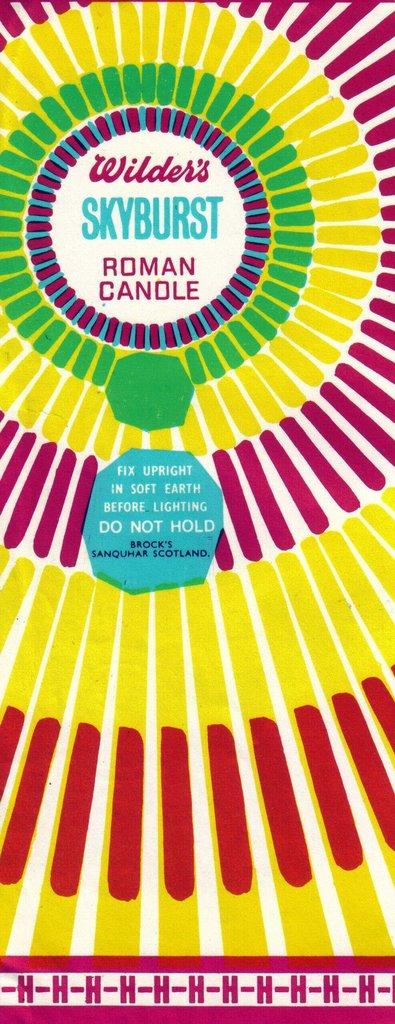What sort of candles are there?
Your answer should be compact. Roman. What is the brand name?
Provide a succinct answer. Wilder's. 